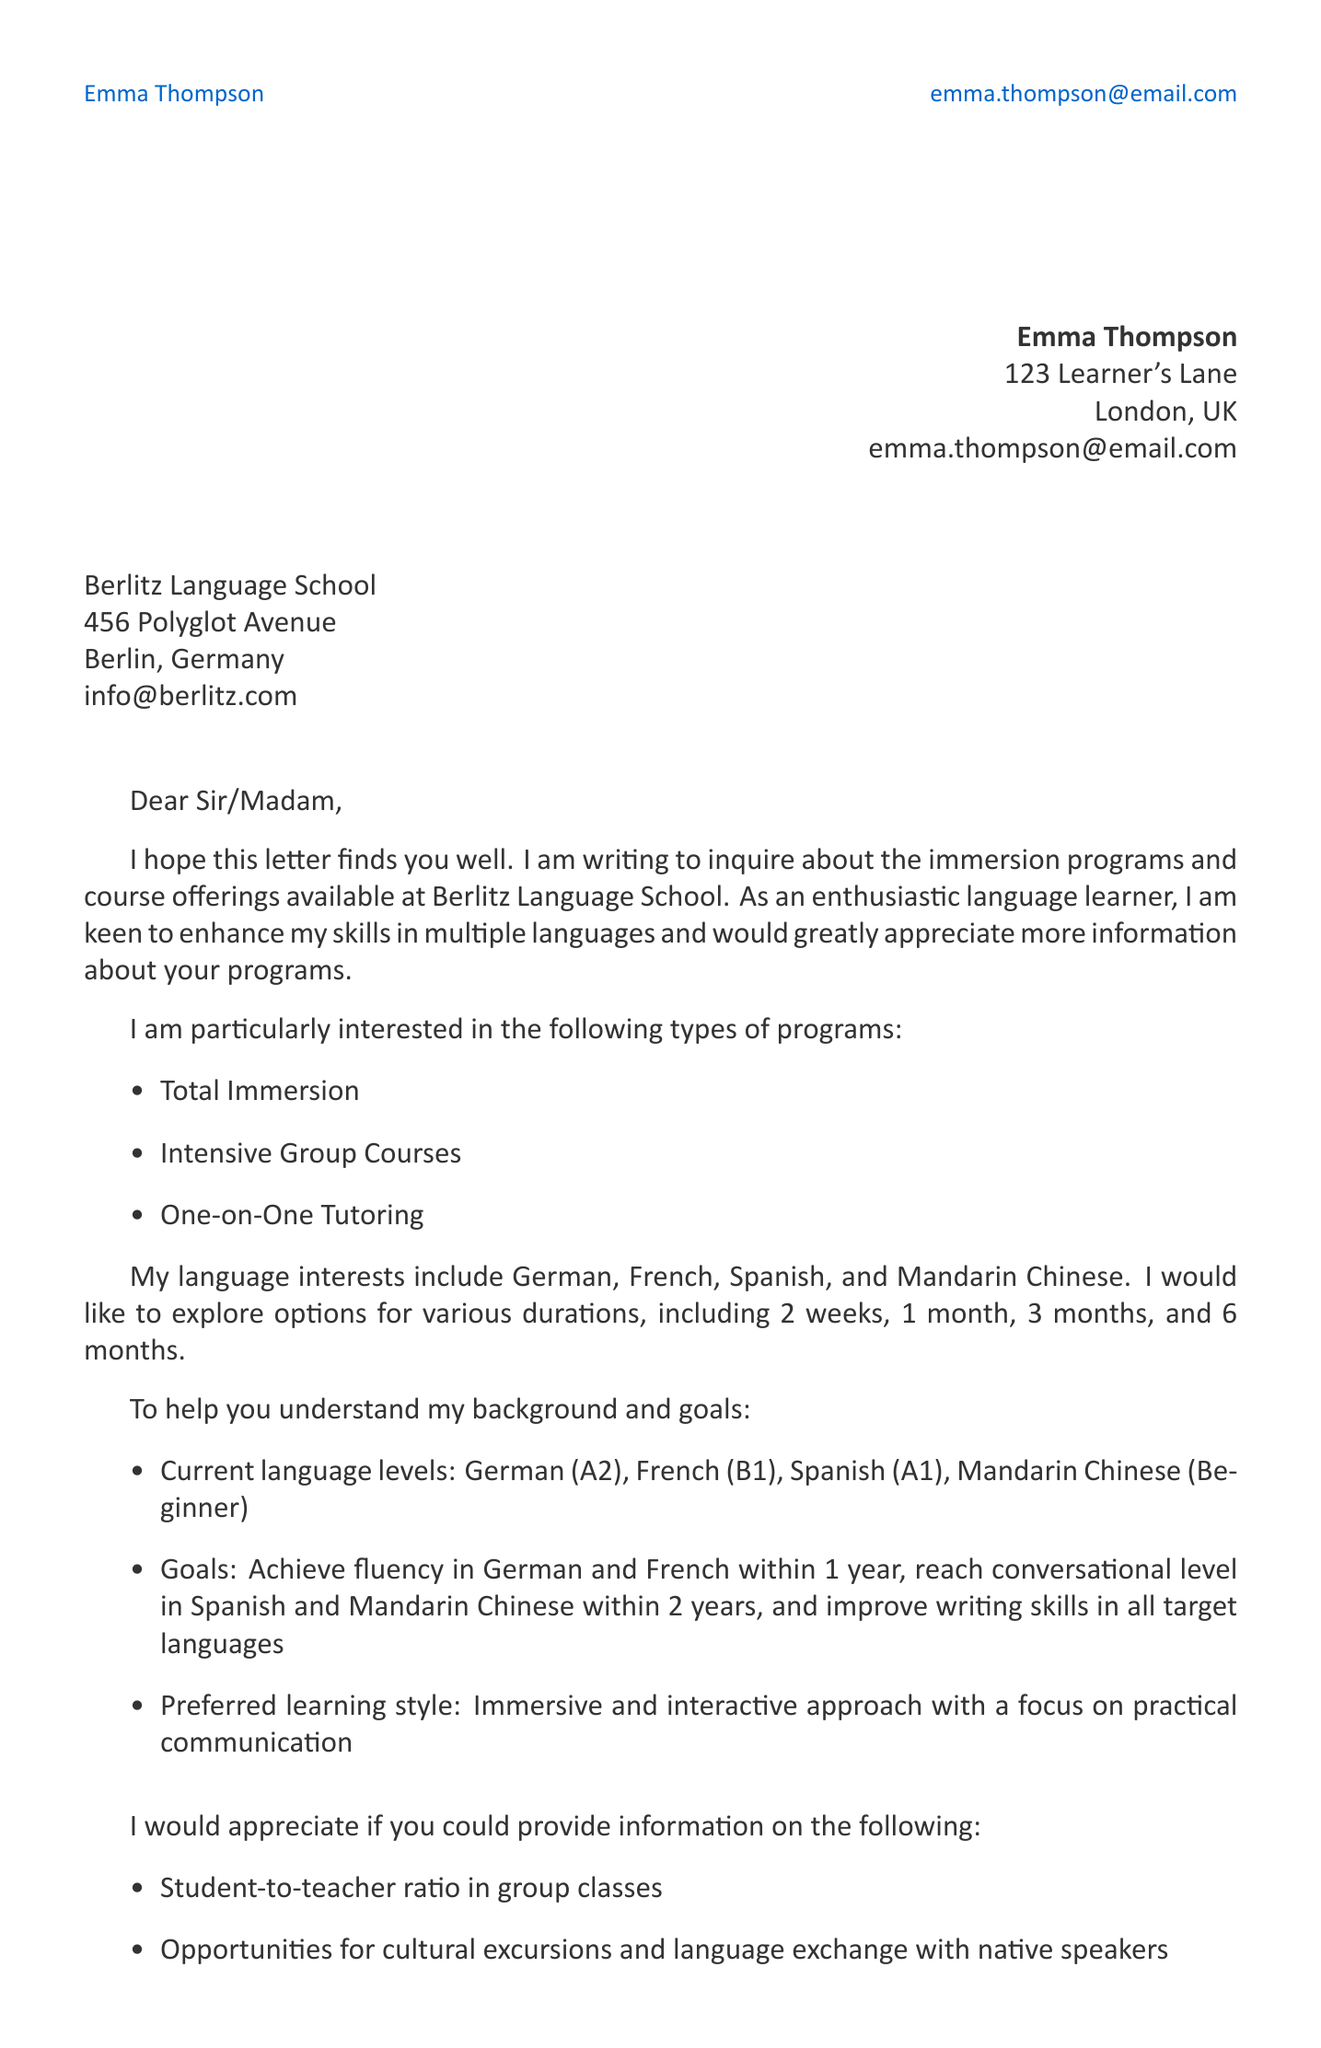What is the sender's name? The sender's name is found at the beginning of the document.
Answer: Emma Thompson What is the email address of the recipient? The recipient's email address is stated in the address block for Berlitz Language School.
Answer: info@berlitz.com What languages is the sender interested in learning? The document lists specific languages of interest in a bullet-point format.
Answer: German, French, Spanish, Mandarin Chinese What is the highest language level the sender has achieved in French? The highest language level in French is explicitly mentioned in the current language levels section.
Answer: B1 What duration options are available for the programs? Duration options are specified in a list format within the inquiry details.
Answer: 2 weeks, 1 month, 3 months, 6 months What specific question does the sender ask about cultural experiences? The sender asks a question regarding cultural excursions in the list of specific questions.
Answer: Opportunities for cultural excursions and language exchange with native speakers What is the sender's preferred learning style? The sender’s preferred learning style is clearly stated within the personal background section.
Answer: Immersive and interactive approach Is there a request for accommodation options? The sender mentions a specific question regarding accommodation in the inquiry details.
Answer: Yes When is the sender available to start? The availability information is mentioned in the closing remarks section of the document.
Answer: Next month 